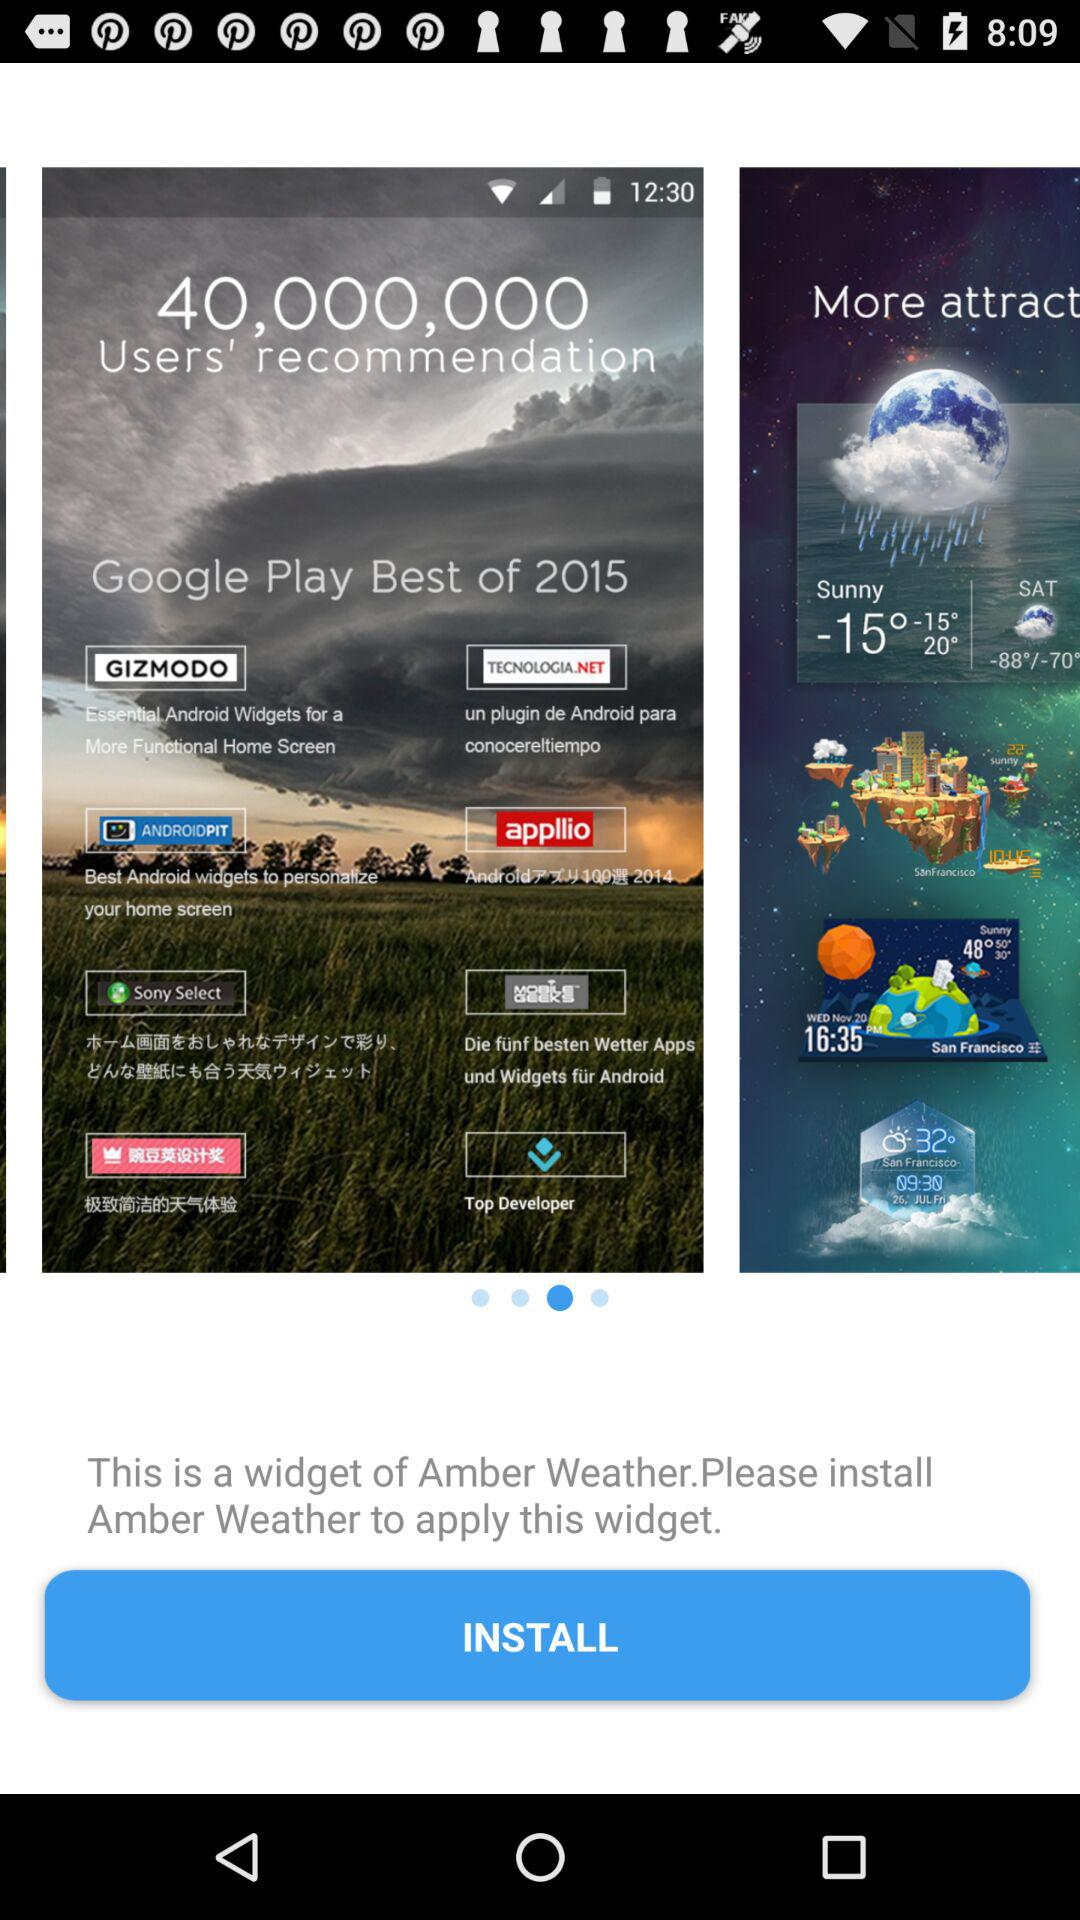How many people recommended? There are 40,000,000 people recommended. 